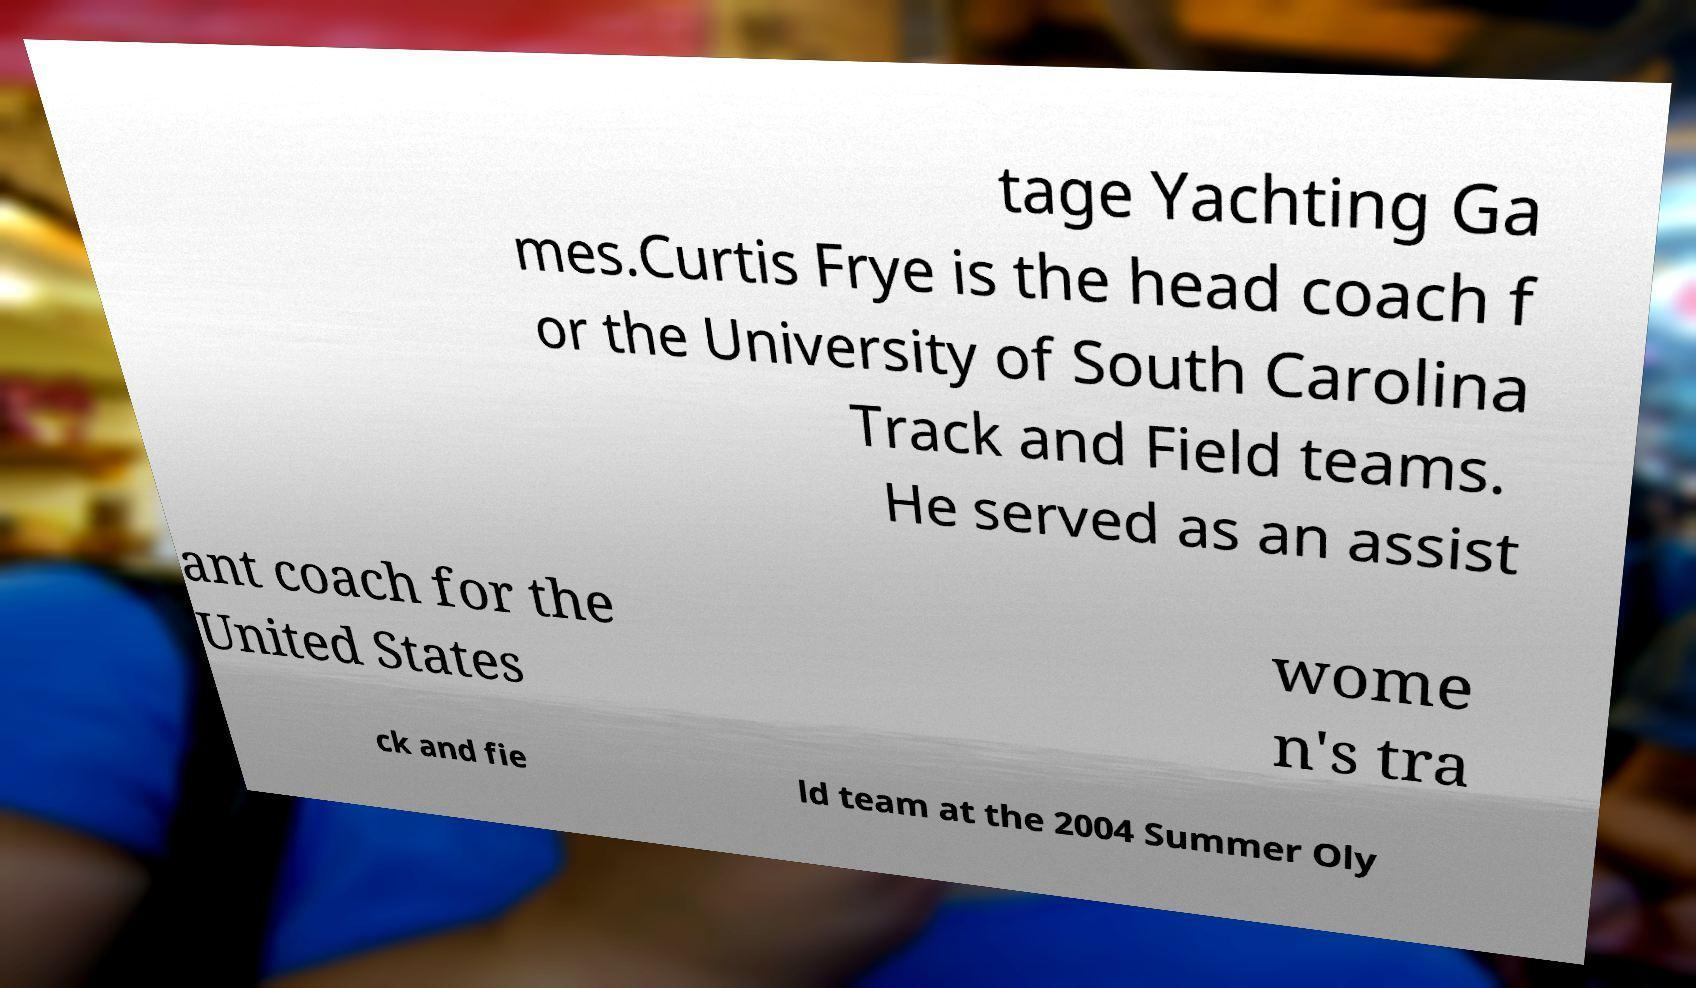Can you accurately transcribe the text from the provided image for me? tage Yachting Ga mes.Curtis Frye is the head coach f or the University of South Carolina Track and Field teams. He served as an assist ant coach for the United States wome n's tra ck and fie ld team at the 2004 Summer Oly 